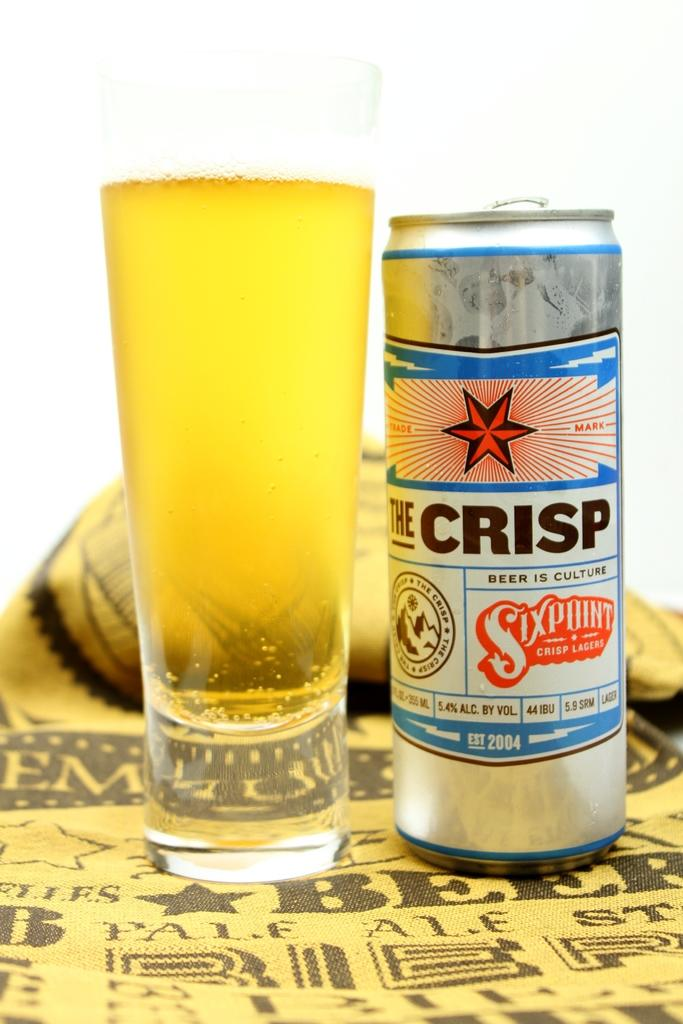<image>
Give a short and clear explanation of the subsequent image. A tin can of beer with the label for the crisp is sitting next to a full glass of beer. 